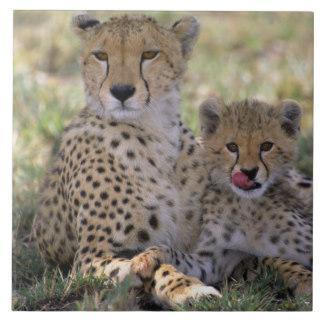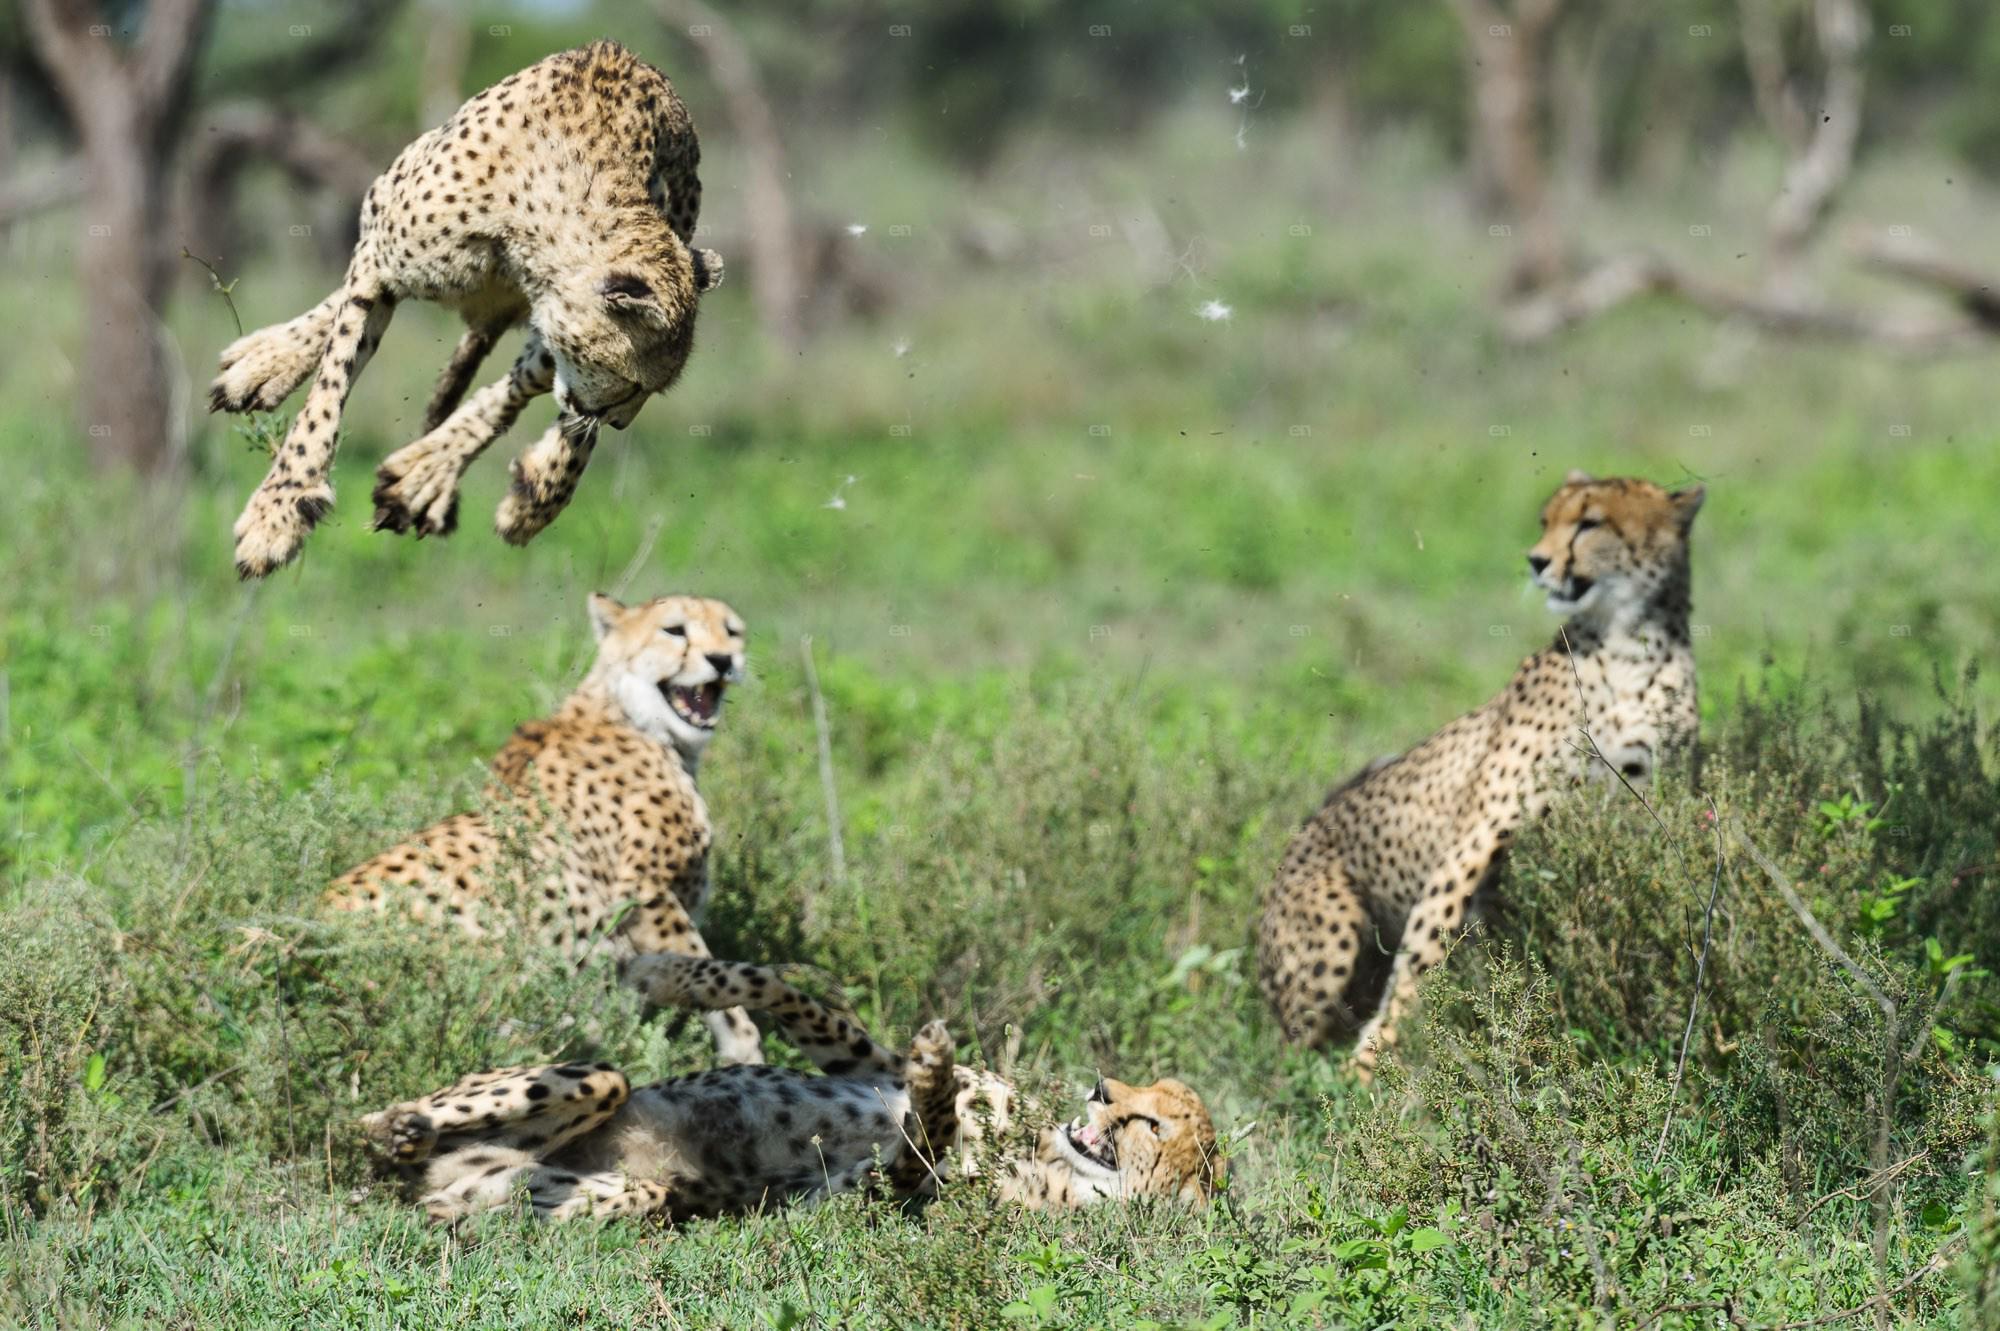The first image is the image on the left, the second image is the image on the right. Examine the images to the left and right. Is the description "There is exactly two cheetahs in the left image." accurate? Answer yes or no. Yes. The first image is the image on the left, the second image is the image on the right. Evaluate the accuracy of this statement regarding the images: "One mother and her cub are sitting in the grass together.". Is it true? Answer yes or no. Yes. 